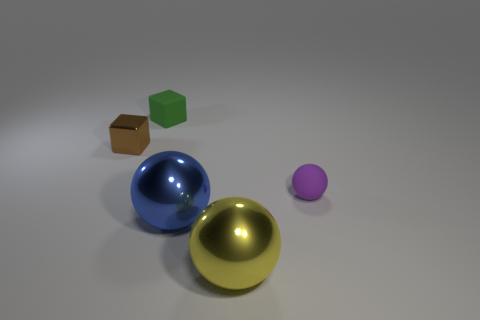There is a small purple rubber thing; is its shape the same as the rubber object that is left of the tiny purple matte thing?
Give a very brief answer. No. What number of objects are both in front of the green thing and on the right side of the small metallic thing?
Offer a very short reply. 3. There is a blue object that is the same shape as the purple rubber object; what is its material?
Provide a short and direct response. Metal. There is a rubber thing left of the tiny matte thing that is in front of the small green object; how big is it?
Provide a succinct answer. Small. Are any cyan matte things visible?
Provide a succinct answer. No. There is a small object that is on the left side of the tiny purple matte ball and in front of the tiny green rubber block; what is its material?
Your answer should be very brief. Metal. Is the number of spheres that are in front of the tiny purple thing greater than the number of yellow metal things that are to the left of the big yellow metal thing?
Keep it short and to the point. Yes. Are there any blue things of the same size as the brown shiny block?
Ensure brevity in your answer.  No. There is a shiny ball that is behind the object in front of the big metallic thing that is behind the big yellow shiny object; how big is it?
Give a very brief answer. Large. What color is the small metal cube?
Make the answer very short. Brown. 